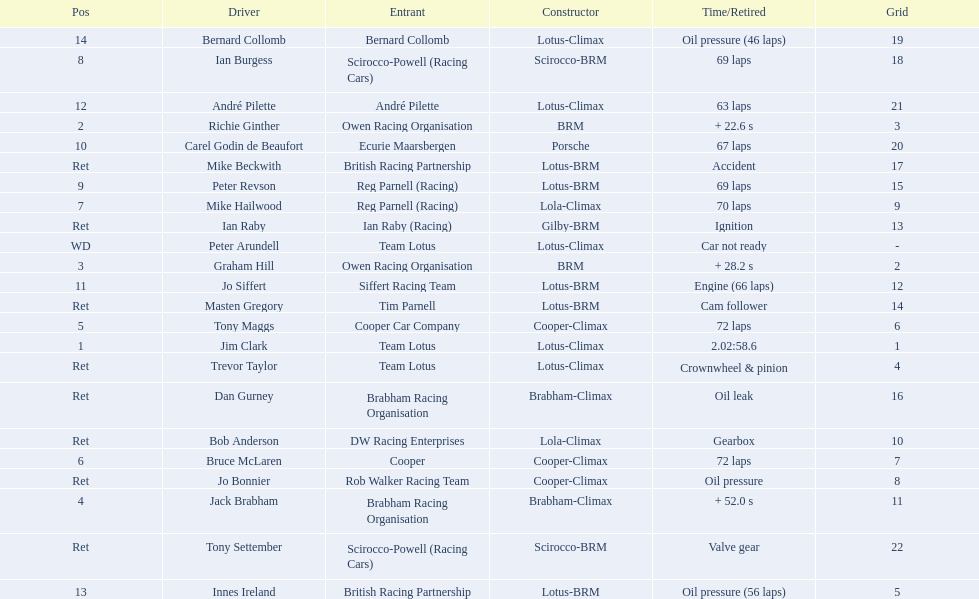What are the listed driver names? Jim Clark, Richie Ginther, Graham Hill, Jack Brabham, Tony Maggs, Bruce McLaren, Mike Hailwood, Ian Burgess, Peter Revson, Carel Godin de Beaufort, Jo Siffert, André Pilette, Innes Ireland, Bernard Collomb, Ian Raby, Dan Gurney, Mike Beckwith, Masten Gregory, Trevor Taylor, Jo Bonnier, Tony Settember, Bob Anderson, Peter Arundell. Could you help me parse every detail presented in this table? {'header': ['Pos', 'Driver', 'Entrant', 'Constructor', 'Time/Retired', 'Grid'], 'rows': [['14', 'Bernard Collomb', 'Bernard Collomb', 'Lotus-Climax', 'Oil pressure (46 laps)', '19'], ['8', 'Ian Burgess', 'Scirocco-Powell (Racing Cars)', 'Scirocco-BRM', '69 laps', '18'], ['12', 'André Pilette', 'André Pilette', 'Lotus-Climax', '63 laps', '21'], ['2', 'Richie Ginther', 'Owen Racing Organisation', 'BRM', '+ 22.6 s', '3'], ['10', 'Carel Godin de Beaufort', 'Ecurie Maarsbergen', 'Porsche', '67 laps', '20'], ['Ret', 'Mike Beckwith', 'British Racing Partnership', 'Lotus-BRM', 'Accident', '17'], ['9', 'Peter Revson', 'Reg Parnell (Racing)', 'Lotus-BRM', '69 laps', '15'], ['7', 'Mike Hailwood', 'Reg Parnell (Racing)', 'Lola-Climax', '70 laps', '9'], ['Ret', 'Ian Raby', 'Ian Raby (Racing)', 'Gilby-BRM', 'Ignition', '13'], ['WD', 'Peter Arundell', 'Team Lotus', 'Lotus-Climax', 'Car not ready', '-'], ['3', 'Graham Hill', 'Owen Racing Organisation', 'BRM', '+ 28.2 s', '2'], ['11', 'Jo Siffert', 'Siffert Racing Team', 'Lotus-BRM', 'Engine (66 laps)', '12'], ['Ret', 'Masten Gregory', 'Tim Parnell', 'Lotus-BRM', 'Cam follower', '14'], ['5', 'Tony Maggs', 'Cooper Car Company', 'Cooper-Climax', '72 laps', '6'], ['1', 'Jim Clark', 'Team Lotus', 'Lotus-Climax', '2.02:58.6', '1'], ['Ret', 'Trevor Taylor', 'Team Lotus', 'Lotus-Climax', 'Crownwheel & pinion', '4'], ['Ret', 'Dan Gurney', 'Brabham Racing Organisation', 'Brabham-Climax', 'Oil leak', '16'], ['Ret', 'Bob Anderson', 'DW Racing Enterprises', 'Lola-Climax', 'Gearbox', '10'], ['6', 'Bruce McLaren', 'Cooper', 'Cooper-Climax', '72 laps', '7'], ['Ret', 'Jo Bonnier', 'Rob Walker Racing Team', 'Cooper-Climax', 'Oil pressure', '8'], ['4', 'Jack Brabham', 'Brabham Racing Organisation', 'Brabham-Climax', '+ 52.0 s', '11'], ['Ret', 'Tony Settember', 'Scirocco-Powell (Racing Cars)', 'Scirocco-BRM', 'Valve gear', '22'], ['13', 'Innes Ireland', 'British Racing Partnership', 'Lotus-BRM', 'Oil pressure (56 laps)', '5']]} Which are tony maggs and jo siffert? Tony Maggs, Jo Siffert. What are their corresponding finishing places? 5, 11. Whose is better? Tony Maggs. 